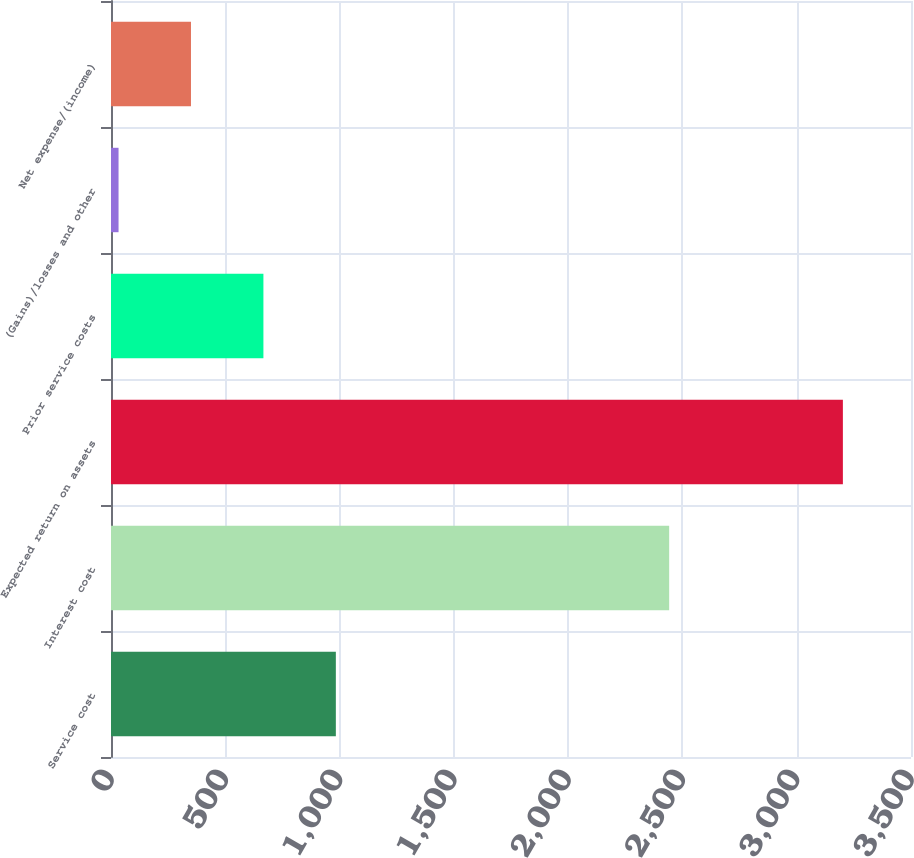<chart> <loc_0><loc_0><loc_500><loc_500><bar_chart><fcel>Service cost<fcel>Interest cost<fcel>Expected return on assets<fcel>Prior service costs<fcel>(Gains)/losses and other<fcel>Net expense/(income)<nl><fcel>983.7<fcel>2442<fcel>3202<fcel>666.8<fcel>33<fcel>349.9<nl></chart> 